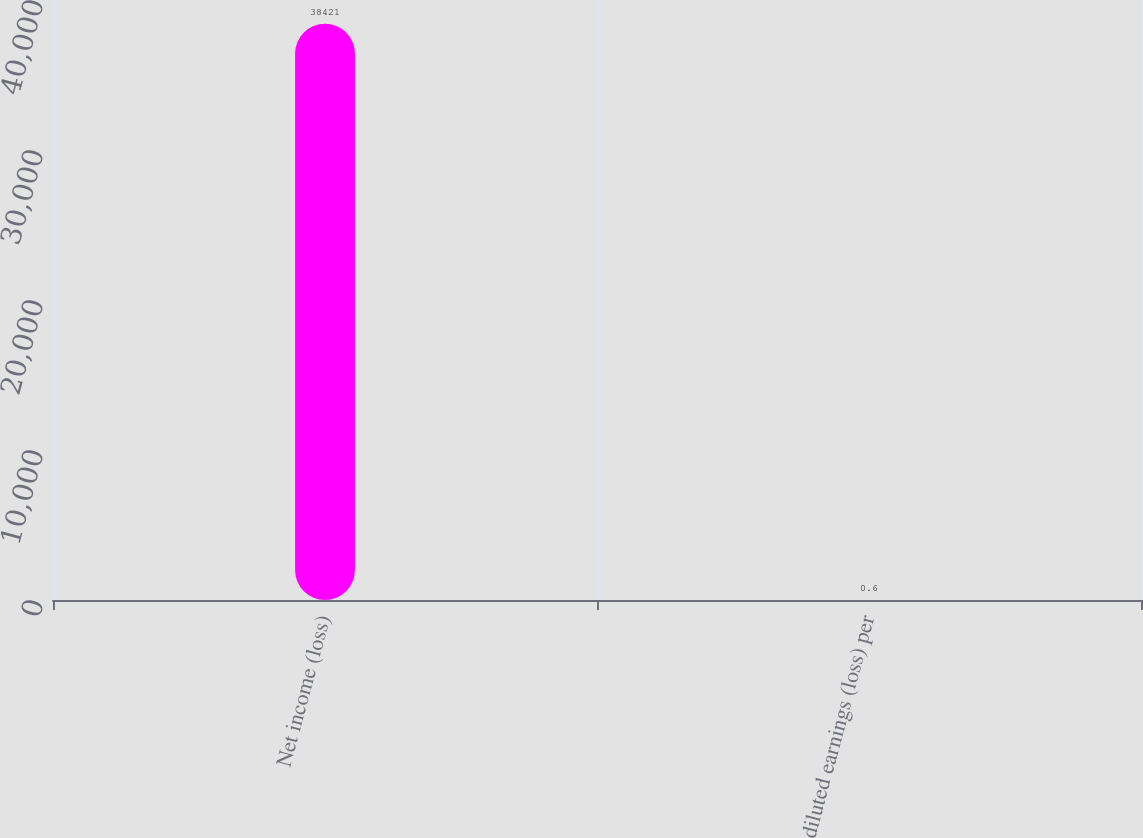Convert chart to OTSL. <chart><loc_0><loc_0><loc_500><loc_500><bar_chart><fcel>Net income (loss)<fcel>diluted earnings (loss) per<nl><fcel>38421<fcel>0.6<nl></chart> 